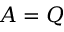Convert formula to latex. <formula><loc_0><loc_0><loc_500><loc_500>A = Q</formula> 